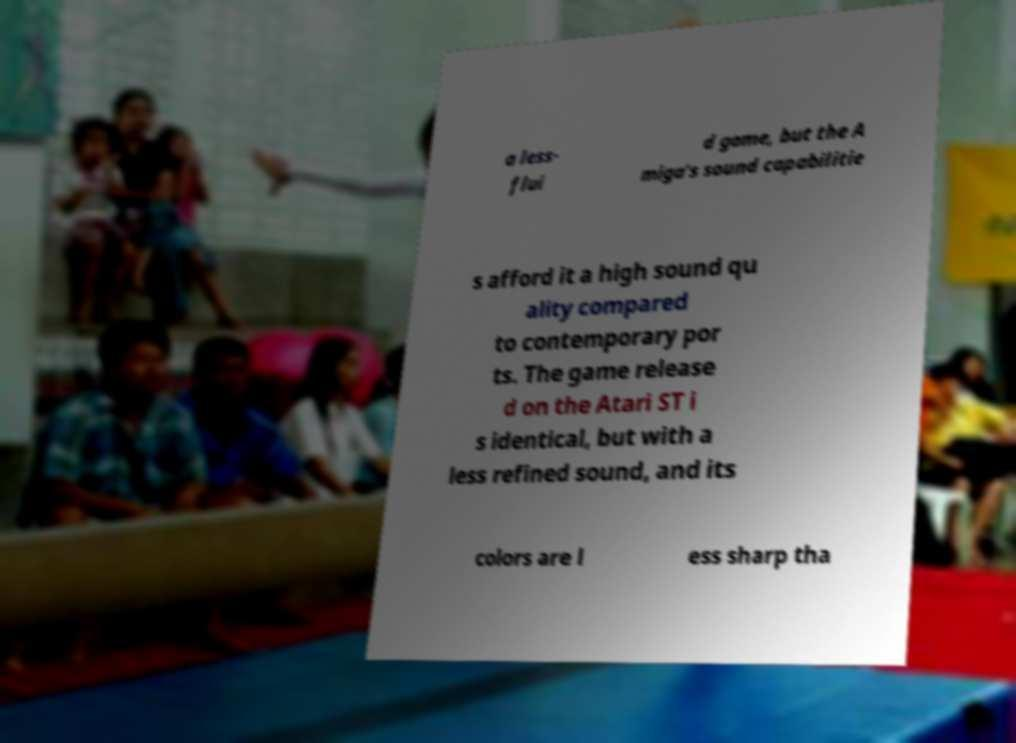What messages or text are displayed in this image? I need them in a readable, typed format. a less- flui d game, but the A miga's sound capabilitie s afford it a high sound qu ality compared to contemporary por ts. The game release d on the Atari ST i s identical, but with a less refined sound, and its colors are l ess sharp tha 